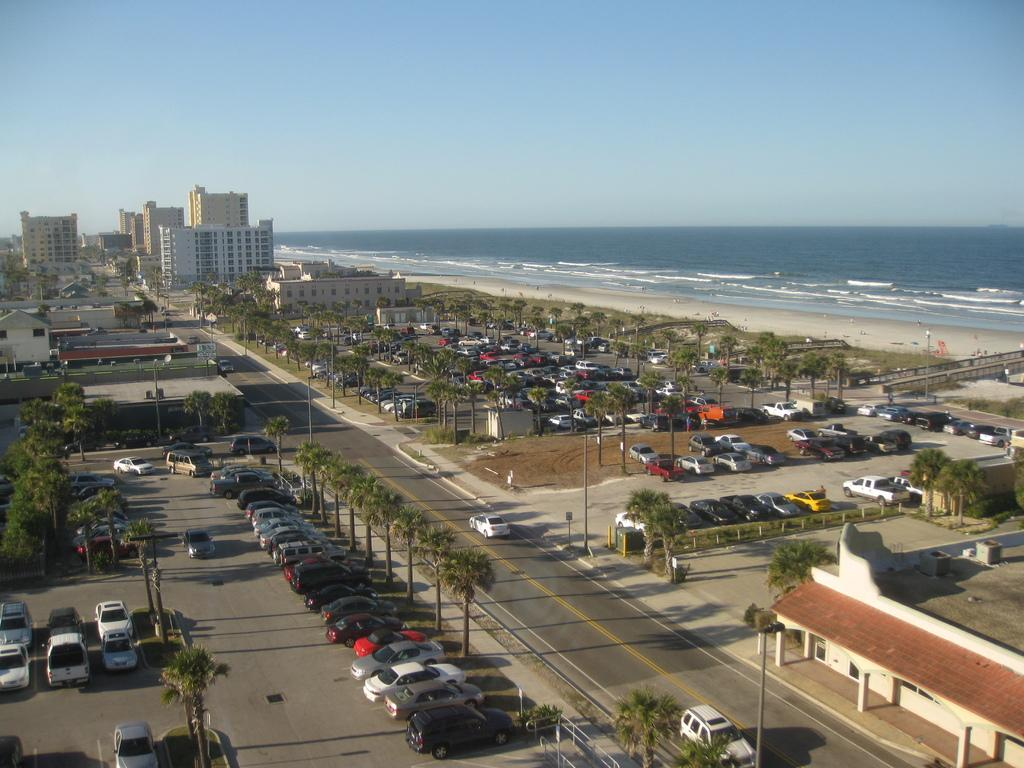What types of objects can be seen in the image? There are vehicles, trees, buildings, and an ocean in the image. Can you describe the natural elements in the image? There are trees and an ocean in the image. What type of structures are present in the image? There are buildings in the image. How does the beggar in the image ask for attention? There is no beggar present in the image. What is your opinion on the vehicles in the image? The conversation does not require an opinion on the vehicles, as we are only discussing the facts present in the image. 